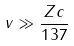Convert formula to latex. <formula><loc_0><loc_0><loc_500><loc_500>v \gg \frac { Z c } { 1 3 7 }</formula> 